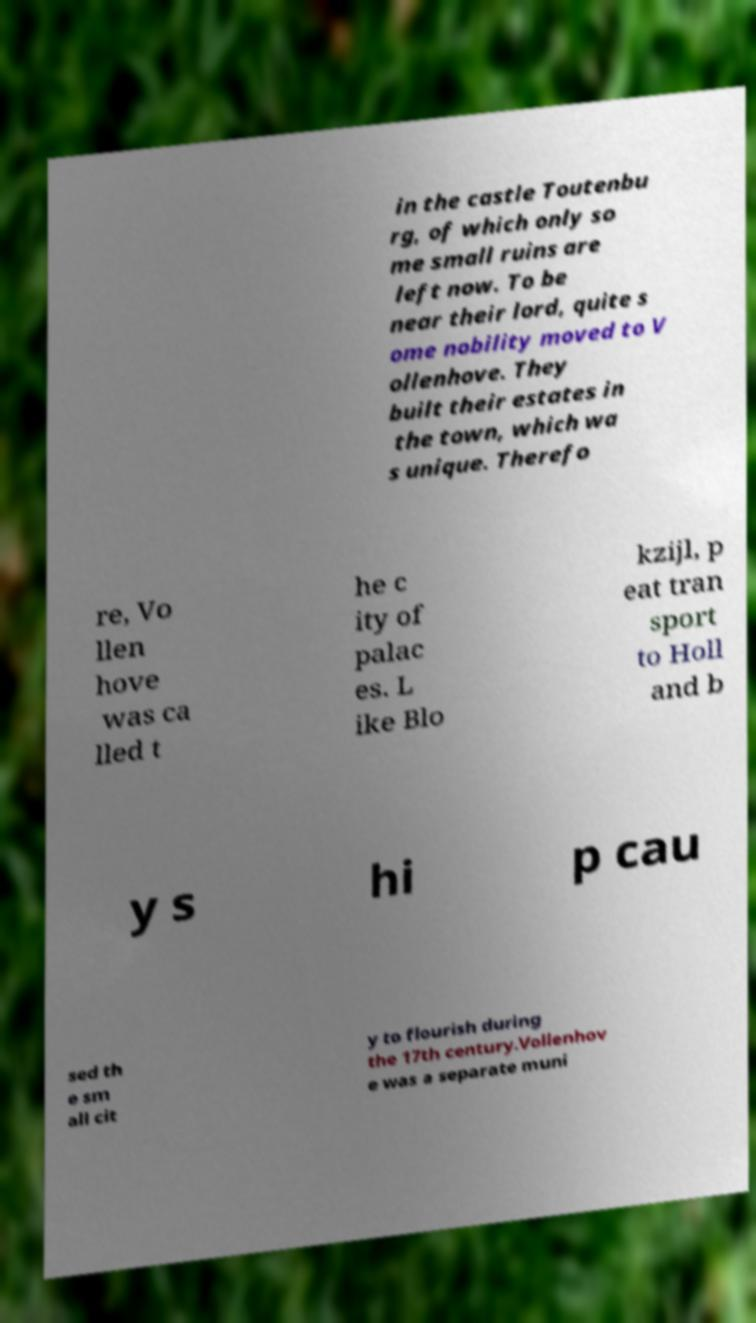For documentation purposes, I need the text within this image transcribed. Could you provide that? in the castle Toutenbu rg, of which only so me small ruins are left now. To be near their lord, quite s ome nobility moved to V ollenhove. They built their estates in the town, which wa s unique. Therefo re, Vo llen hove was ca lled t he c ity of palac es. L ike Blo kzijl, p eat tran sport to Holl and b y s hi p cau sed th e sm all cit y to flourish during the 17th century.Vollenhov e was a separate muni 